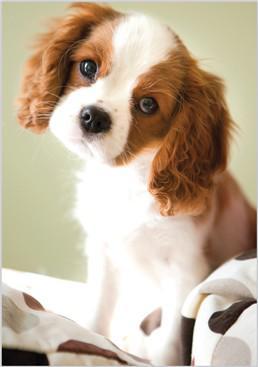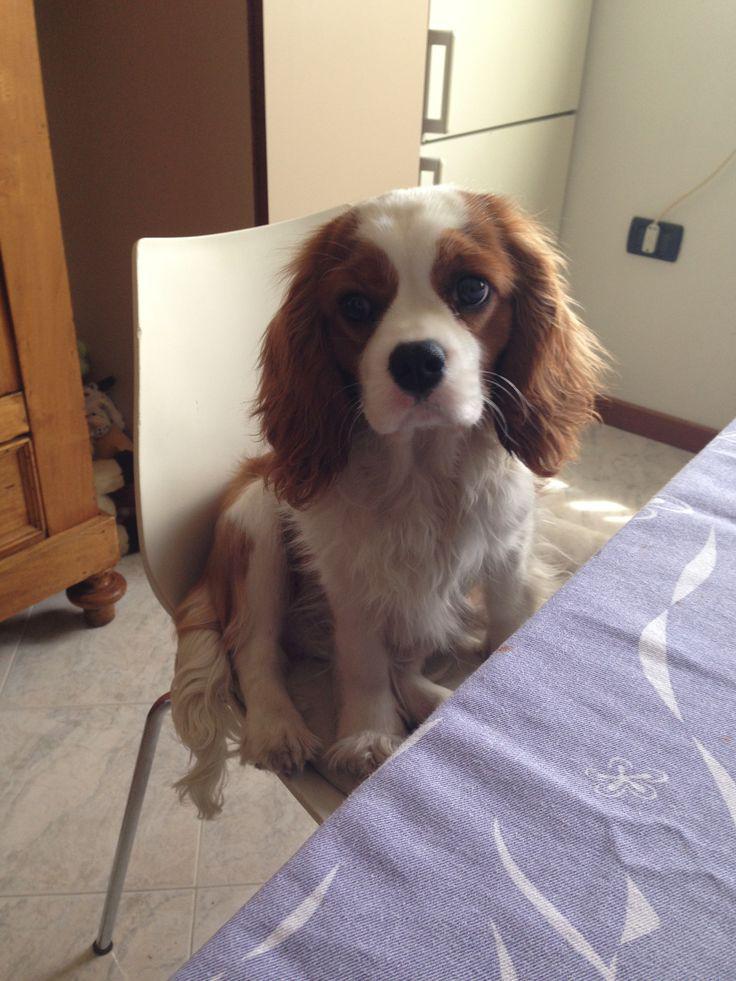The first image is the image on the left, the second image is the image on the right. Evaluate the accuracy of this statement regarding the images: "There is a total of 1 collar on a small dog.". Is it true? Answer yes or no. No. The first image is the image on the left, the second image is the image on the right. For the images shown, is this caption "A brown and white puppy has its head cocked to the left." true? Answer yes or no. No. 